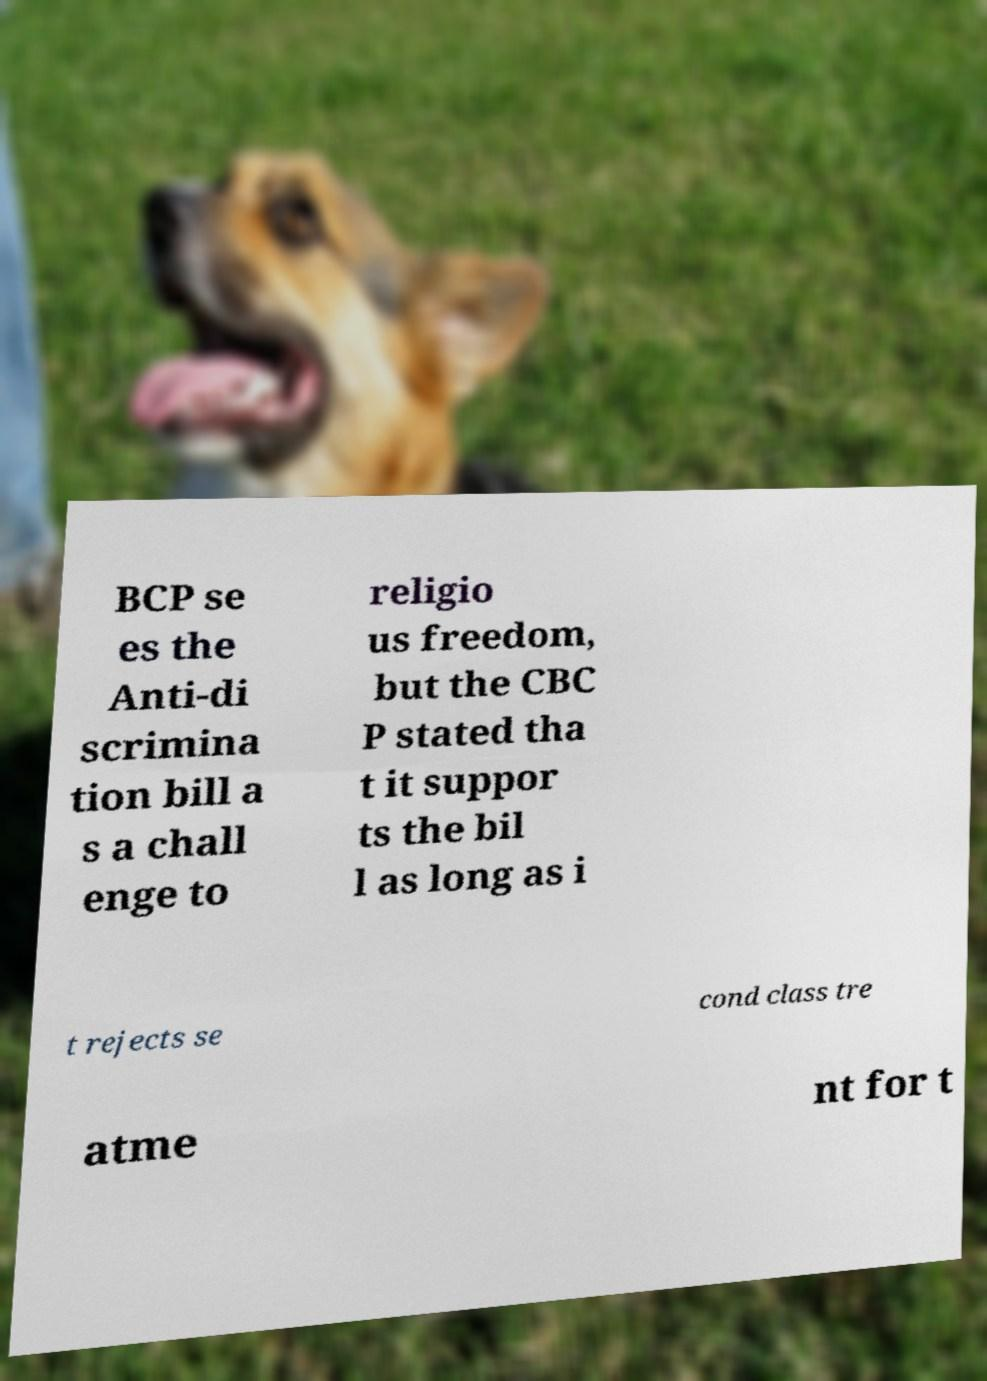Could you extract and type out the text from this image? BCP se es the Anti-di scrimina tion bill a s a chall enge to religio us freedom, but the CBC P stated tha t it suppor ts the bil l as long as i t rejects se cond class tre atme nt for t 